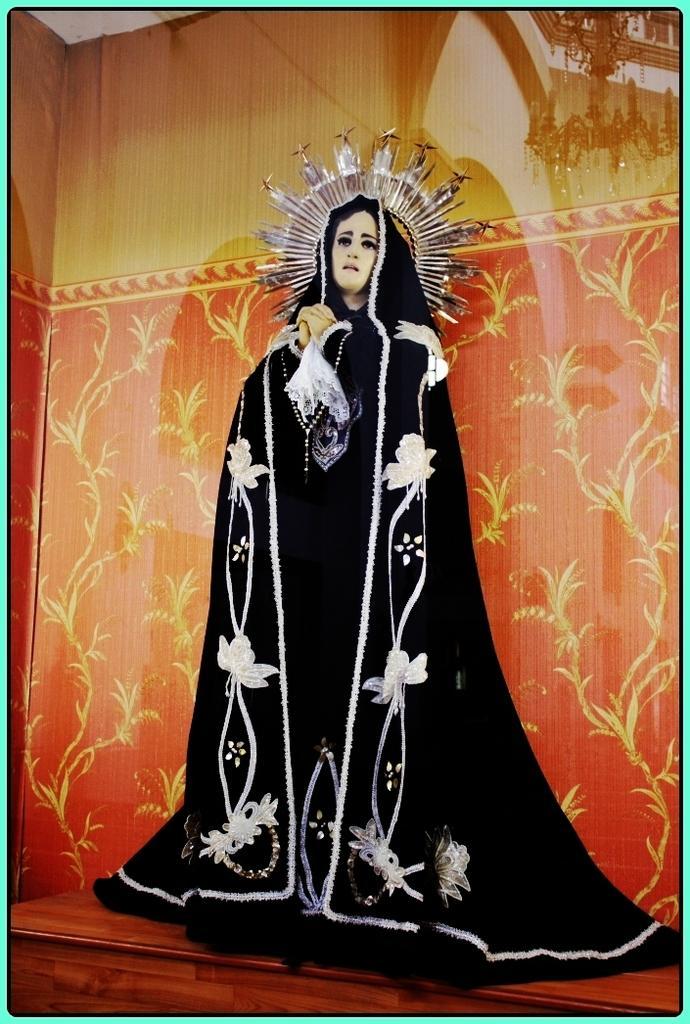In one or two sentences, can you explain what this image depicts? In this image in the center there is a statue and in the background there is a wall. 